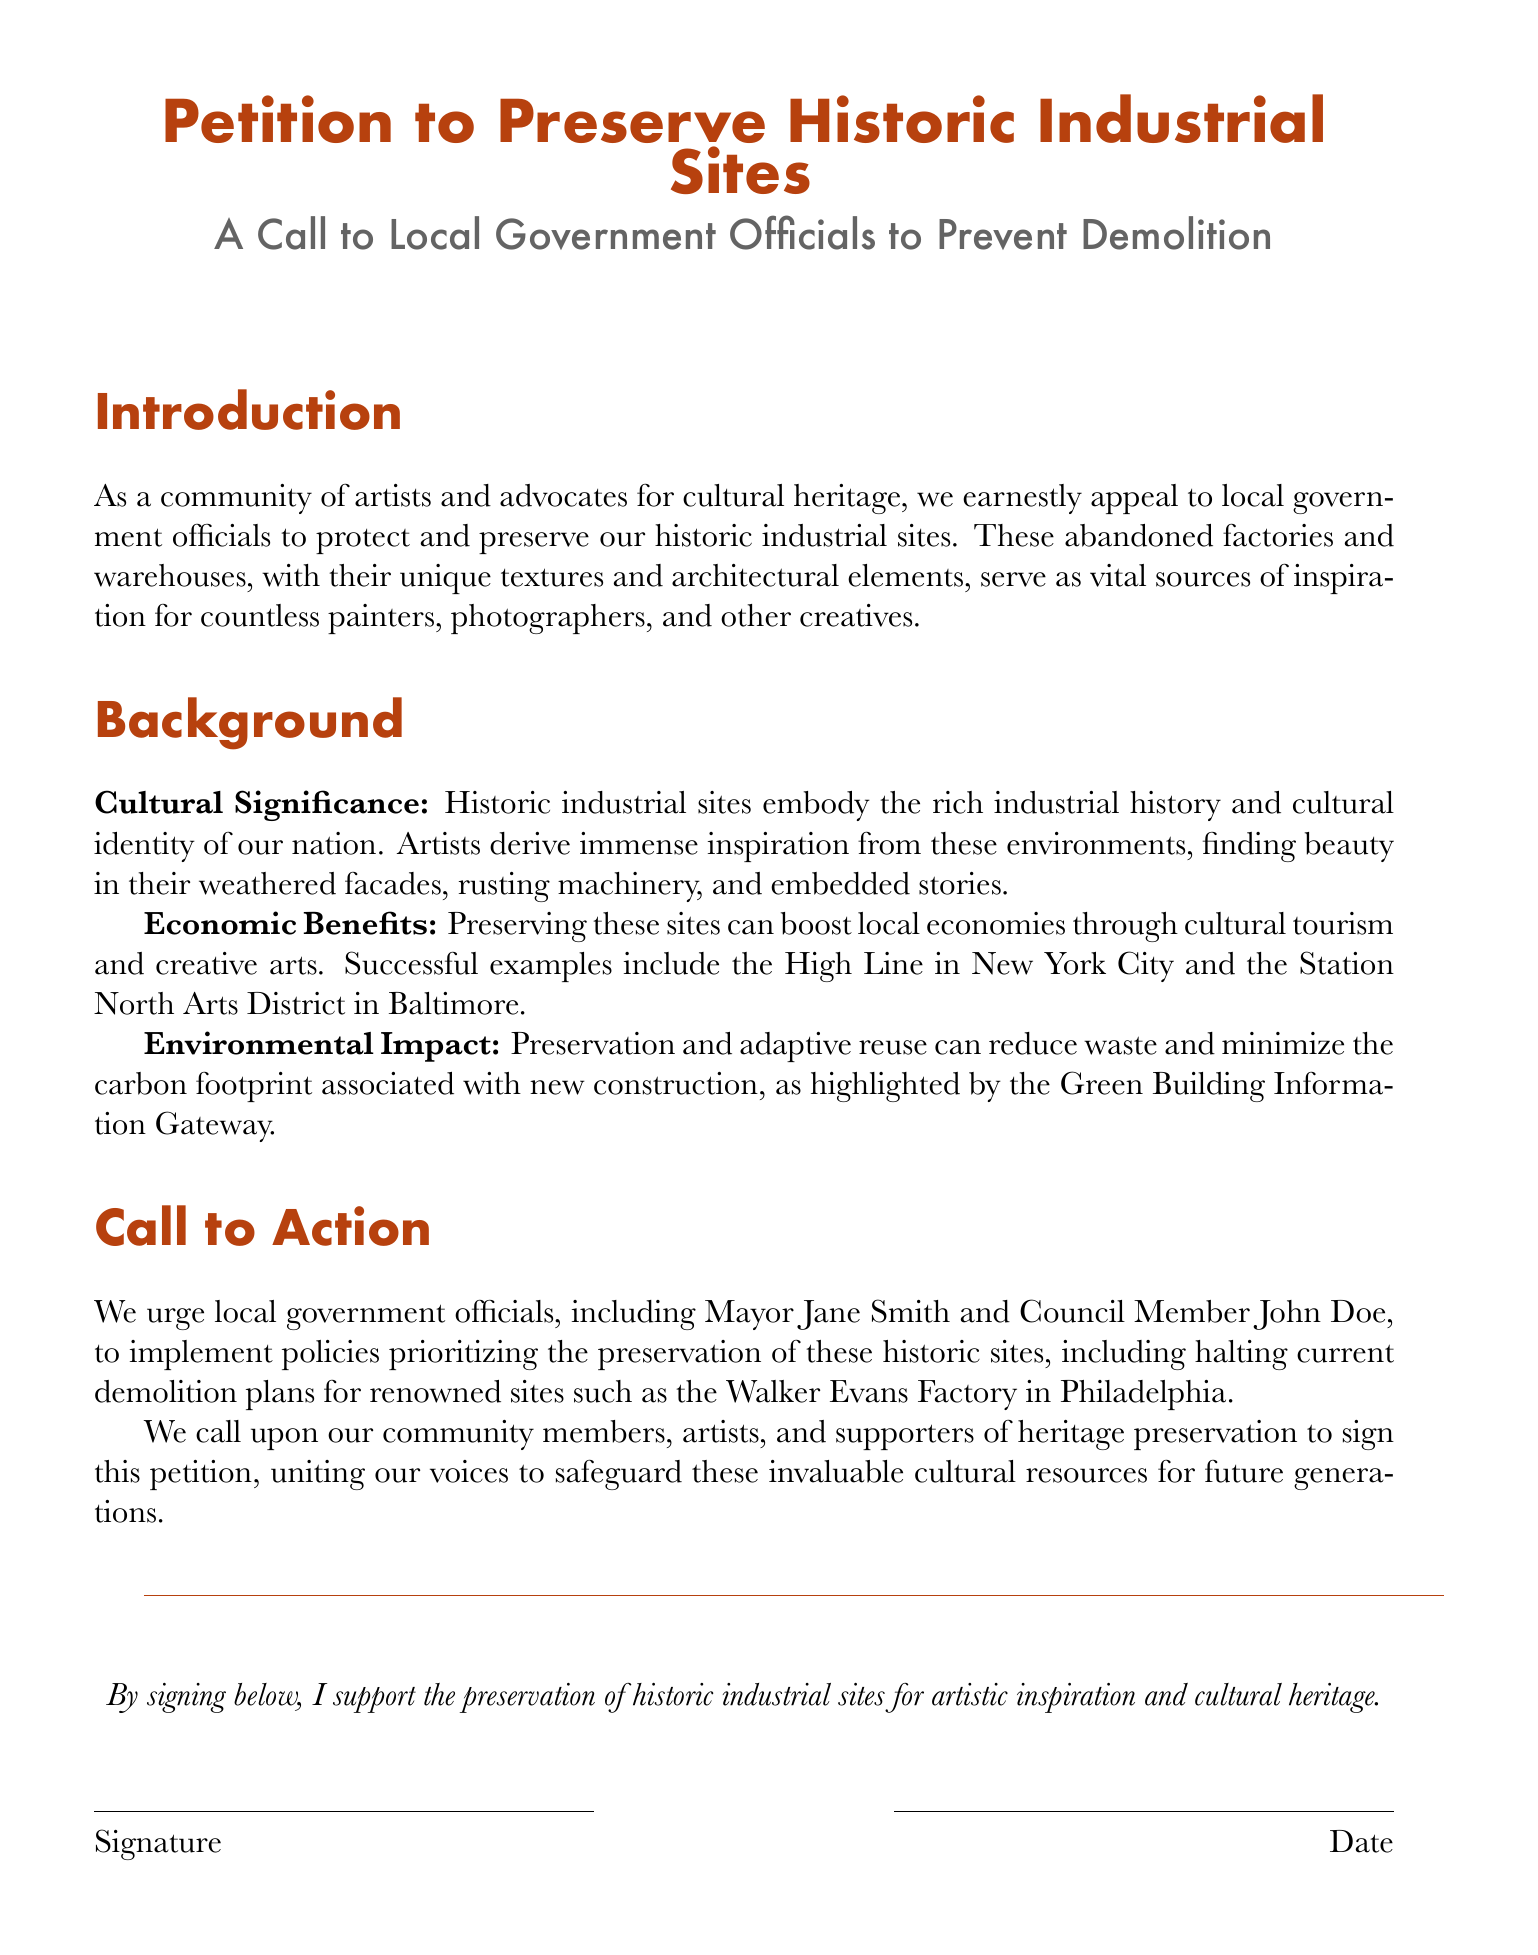What is the title of the petition? The title is explicitly stated at the top of the document as "Petition to Preserve Historic Industrial Sites."
Answer: Petition to Preserve Historic Industrial Sites Who is the targeted audience for this petition? The petition is addressed to "local government officials," which is specified in the introduction.
Answer: local government officials What site is mentioned specifically in the call to action? The document highlights "the Walker Evans Factory in Philadelphia" as a notable site in the call to action.
Answer: Walker Evans Factory in Philadelphia What is one benefit of preserving these sites mentioned in the background? The document states that preserving these sites can boost "local economies through cultural tourism."
Answer: local economies through cultural tourism Who is the first local government official mentioned in the call to action? The petition identifies "Mayor Jane Smith" as the first official in the call to action.
Answer: Mayor Jane Smith What kind of artists does the petition mention? It mentions "painters, photographers, and other creatives," emphasizing the range of artists inspired by these sites.
Answer: painters, photographers, and other creatives What is urged in the call to action regarding current demolition plans? The petition urges to "halt current demolition plans," advocating for the preservation of sites.
Answer: halt current demolition plans What color is used for the title of the petition? The title is presented in "rustyred," which is specified in the document.
Answer: rustyred What must individuals do to show their support for the petition? The document states that individuals must sign below to support the petition.
Answer: sign below 